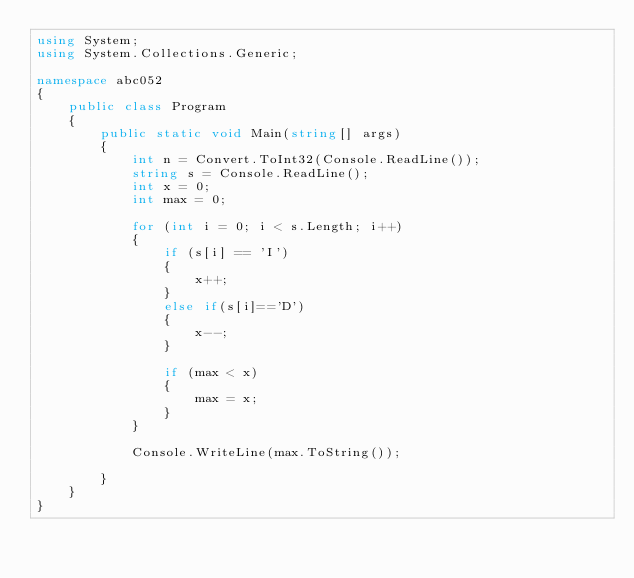Convert code to text. <code><loc_0><loc_0><loc_500><loc_500><_C#_>using System;
using System.Collections.Generic;

namespace abc052
{
    public class Program
    {
        public static void Main(string[] args)
        {
            int n = Convert.ToInt32(Console.ReadLine());
            string s = Console.ReadLine();
            int x = 0;
            int max = 0;

            for (int i = 0; i < s.Length; i++)
            {
                if (s[i] == 'I')
                {
                    x++;
                }
                else if(s[i]=='D')
                {
                    x--;
                }

                if (max < x)
                {
                    max = x;
                }
            }

            Console.WriteLine(max.ToString());

        }
    }
}
</code> 